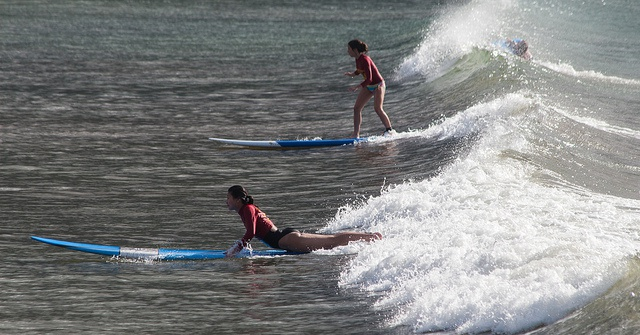Describe the objects in this image and their specific colors. I can see people in gray, black, and lightpink tones, surfboard in gray, blue, and lightblue tones, people in gray, black, and brown tones, surfboard in gray, black, and navy tones, and people in gray, darkgray, lightgray, and lightblue tones in this image. 